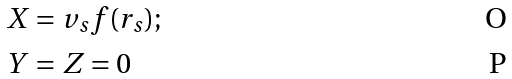<formula> <loc_0><loc_0><loc_500><loc_500>& X = v _ { s } f ( r _ { s } ) ; \\ & Y = Z = 0</formula> 